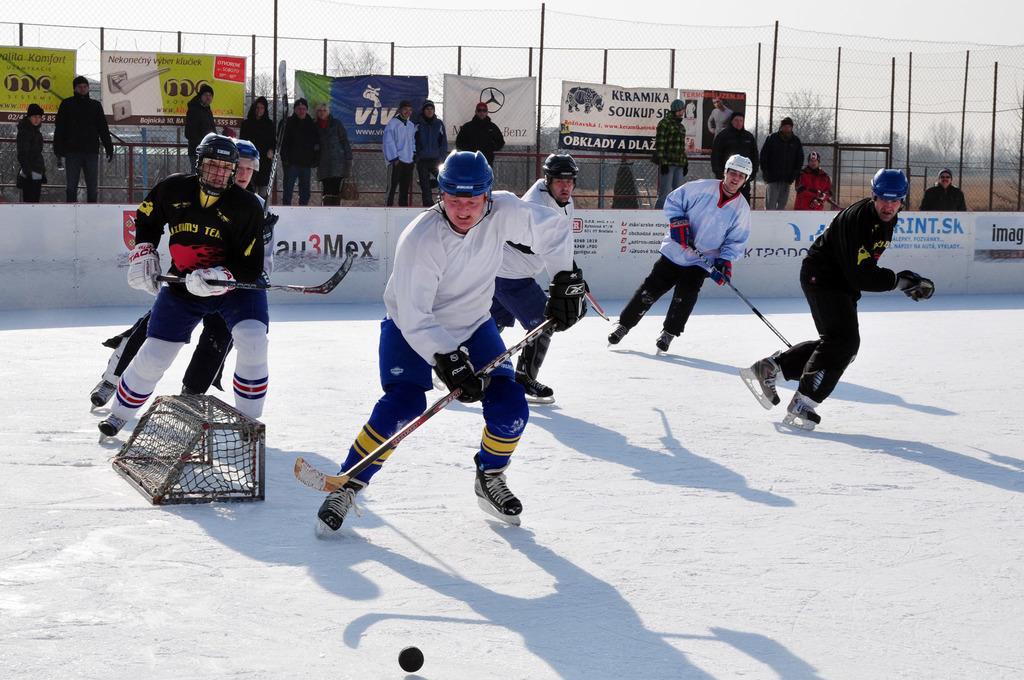Can you describe this image briefly? In this picture we can see a group of people standing on the ground,they are holding sticks,here we can see a ball and in the background we can see persons,fence,banners,poles. 